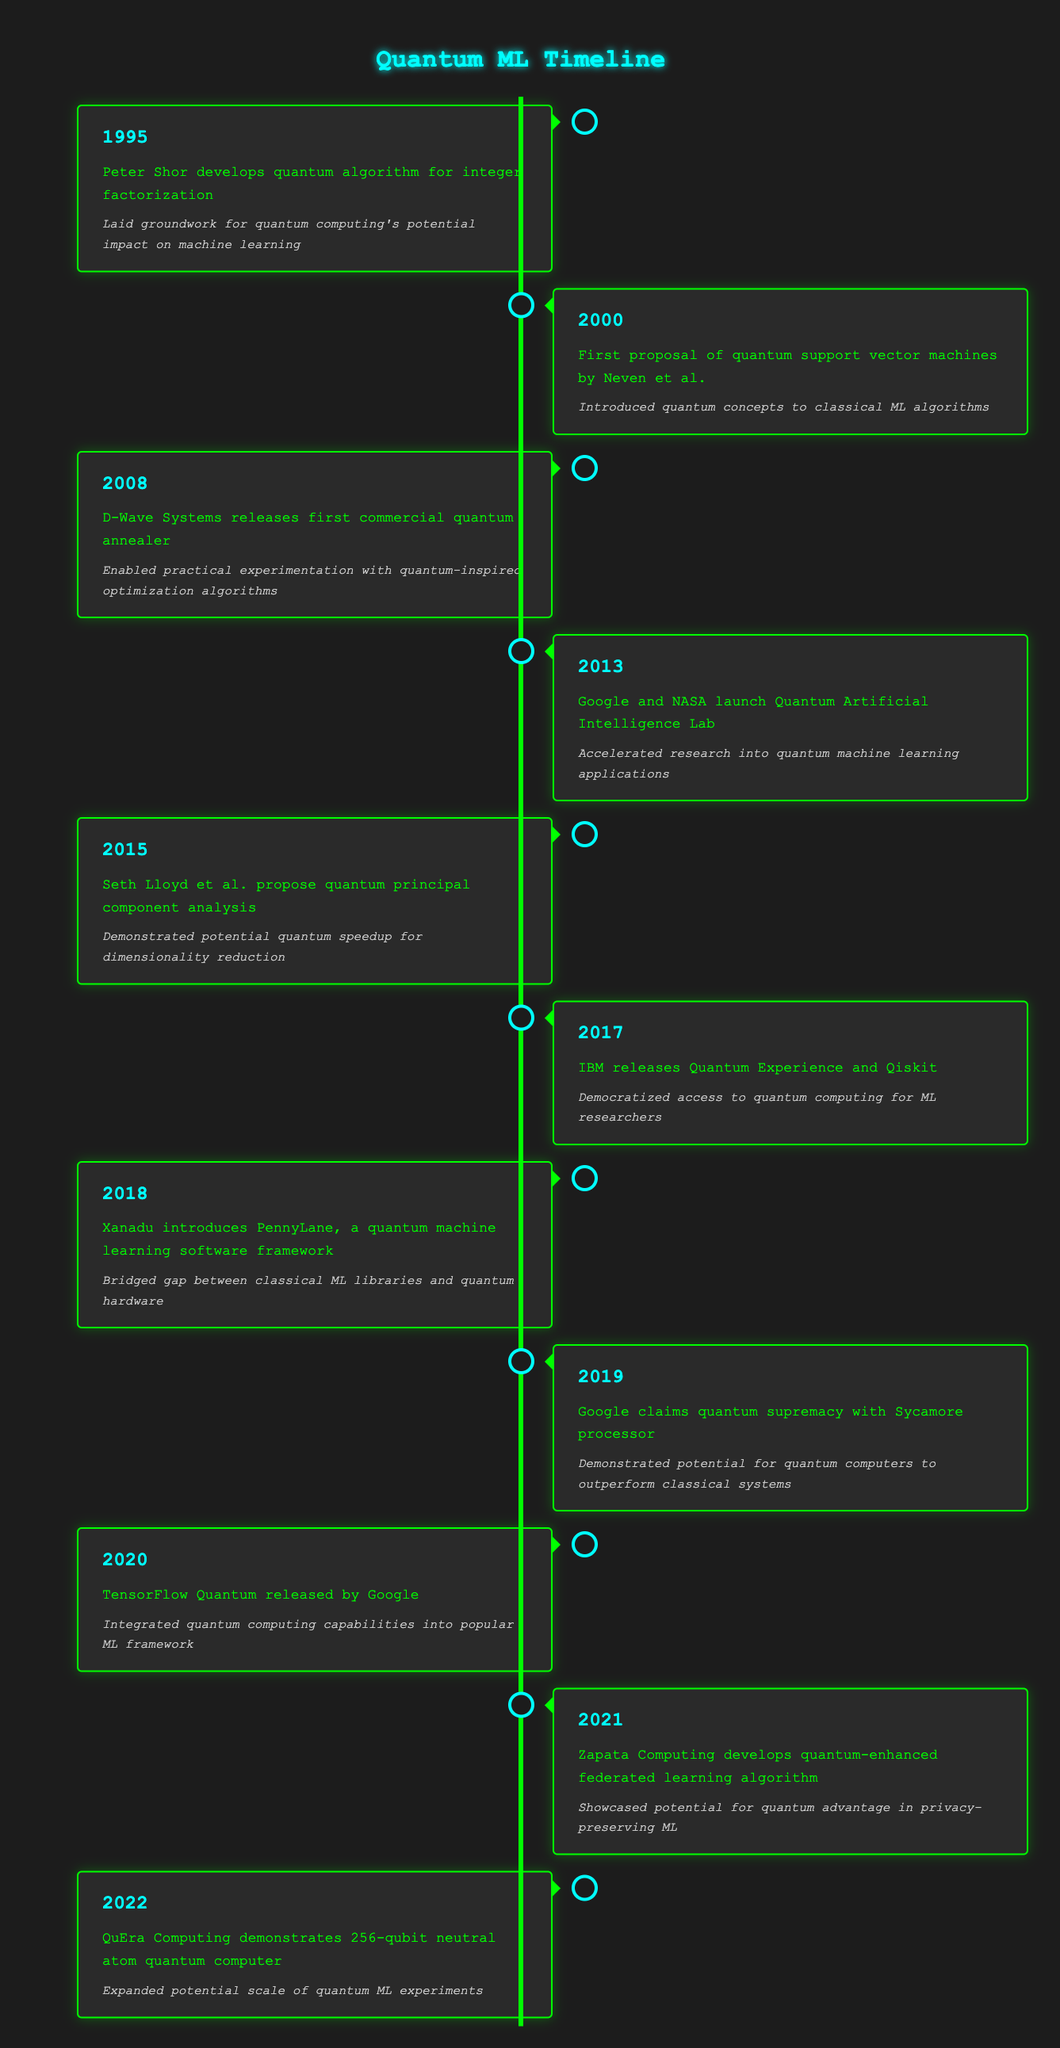What event in 2015 demonstrated potential quantum speedup for dimensionality reduction? The event that demonstrated potential quantum speedup for dimensionality reduction in 2015 was Seth Lloyd et al. proposing quantum principal component analysis. This is directly retrievable from the table by looking for the year 2015.
Answer: Quantum principal component analysis What year did Google claim quantum supremacy with the Sycamore processor? From the table, the event where Google claimed quantum supremacy with the Sycamore processor occurred in 2019. This can be identified by locating the event's description that includes "quantum supremacy" and finding the corresponding year beside it.
Answer: 2019 Which milestone marked the beginning of practical experimentation with quantum-inspired optimization algorithms? The milestone that marked the beginning of practical experimentation with quantum-inspired optimization algorithms was D-Wave Systems releasing the first commercial quantum annealer in 2008. This can be found by reviewing the event descriptions for keywords associated with "practical experimentation" and finding the year connected to that event.
Answer: 2008 How many milestones occurred between 2010 and 2020? To find the number of milestones between 2010 and 2020, we need to count the events listed in that range. The years in that range with milestones are 2013, 2015, 2017, 2018, 2019, and 2020, which gives us a total of 6 events. We identify the years in the table and tally them.
Answer: 6 Did Xanadu's introduction of PennyLane occur before or after IBM released Qiskit? From the table, Xanadu's introduction of PennyLane occurred in 2018 and IBM released Qiskit in 2017. Therefore, Xanadu's introduction happened after IBM's release of Qiskit. By comparing the two years directly, we can see that 2018 is greater than 2017.
Answer: After What is the significance of the milestone when Google and NASA launched the Quantum Artificial Intelligence Lab? The significance of the milestone when Google and NASA launched the Quantum Artificial Intelligence Lab in 2013 is that it accelerated research into quantum machine learning applications. This significance can be extracted from the table by identifying the specific event and its corresponding significance.
Answer: Accelerated research into quantum machine learning applications What is the average year of the milestones listed in the timeline? To find the average year of the milestones, first sum all the years: 1995 + 2000 + 2008 + 2013 + 2015 + 2017 + 2018 + 2019 + 2020 + 2021 + 2022 =  2218. There are 11 milestones, so the average is 2218 divided by 11, which equals approximately 201.64. Therefore, the average year is 2010. In summary, this involves basic arithmetic: finding the total and dividing by the number of items.
Answer: 2010 What role did TensorFlow Quantum play in the development of quantum machine learning? TensorFlow Quantum, released by Google in 2020, integrated quantum computing capabilities into a popular machine learning framework, thereby facilitating the connection between quantum computing and machine learning. This can be seen by referring to the significance associated with that specific event in the table.
Answer: Integrated quantum computing capabilities into popular ML framework 